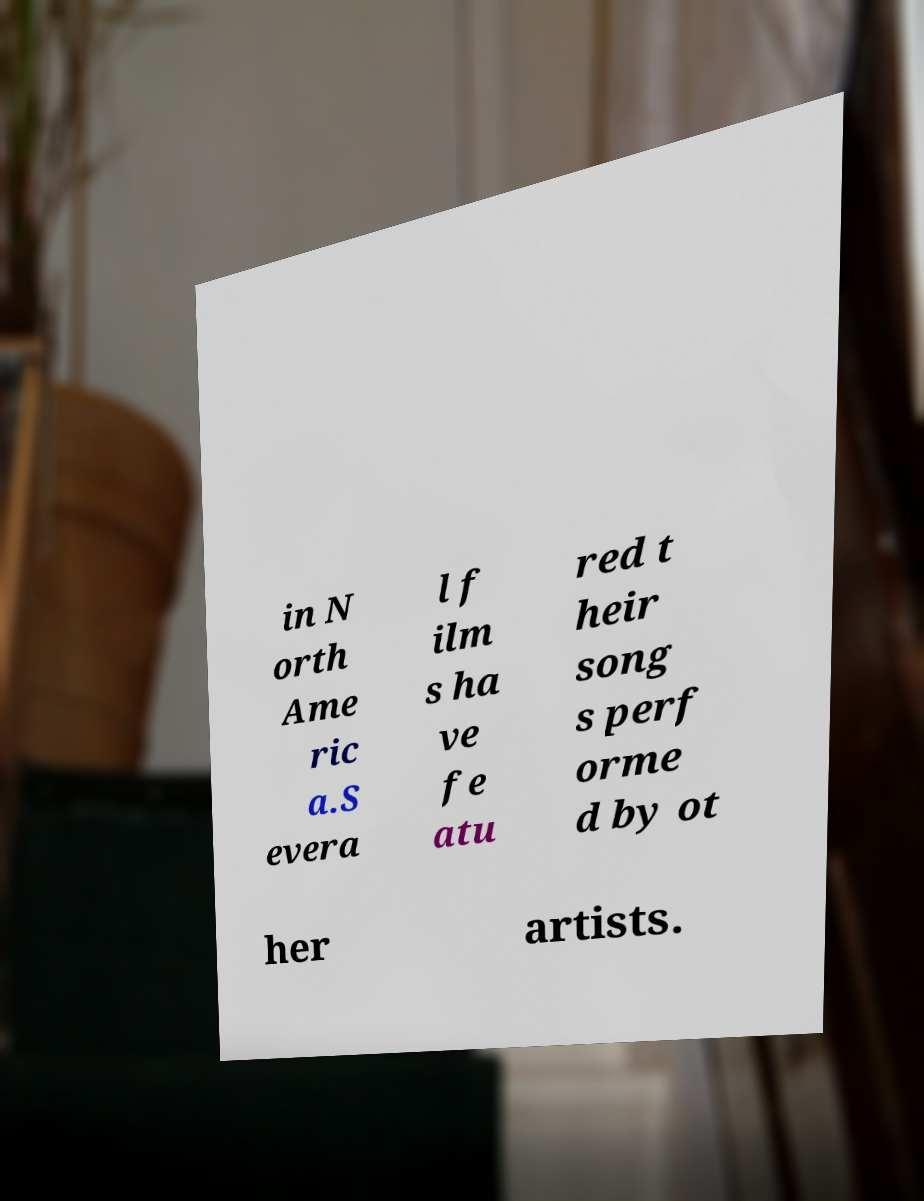Can you accurately transcribe the text from the provided image for me? in N orth Ame ric a.S evera l f ilm s ha ve fe atu red t heir song s perf orme d by ot her artists. 